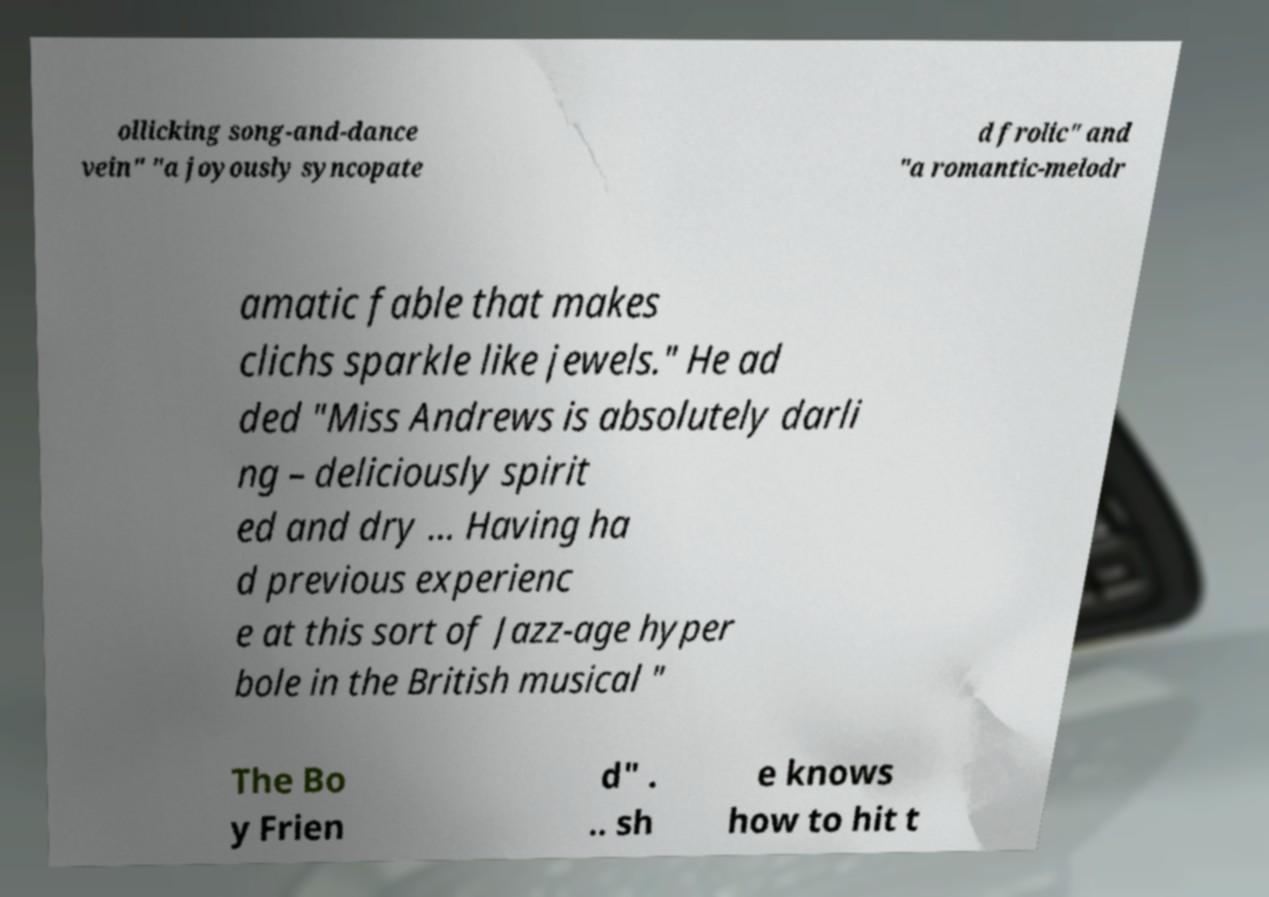Please identify and transcribe the text found in this image. ollicking song-and-dance vein" "a joyously syncopate d frolic" and "a romantic-melodr amatic fable that makes clichs sparkle like jewels." He ad ded "Miss Andrews is absolutely darli ng – deliciously spirit ed and dry ... Having ha d previous experienc e at this sort of Jazz-age hyper bole in the British musical " The Bo y Frien d" . .. sh e knows how to hit t 